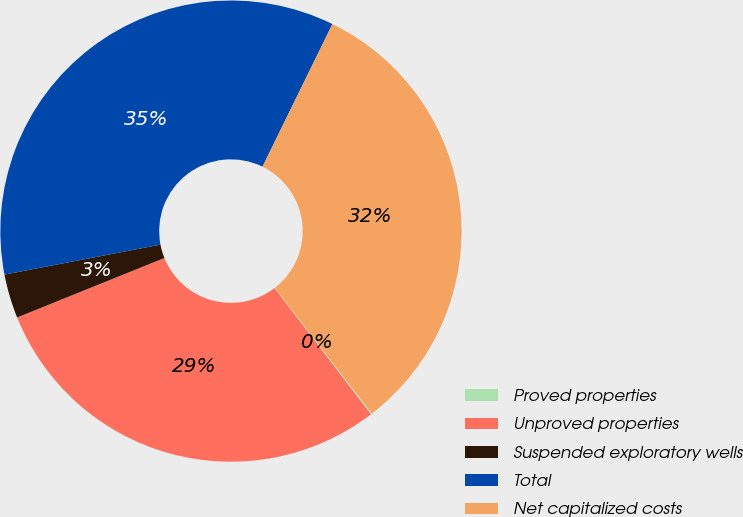Convert chart to OTSL. <chart><loc_0><loc_0><loc_500><loc_500><pie_chart><fcel>Proved properties<fcel>Unproved properties<fcel>Suspended exploratory wells<fcel>Total<fcel>Net capitalized costs<nl><fcel>0.09%<fcel>29.27%<fcel>3.09%<fcel>35.27%<fcel>32.27%<nl></chart> 